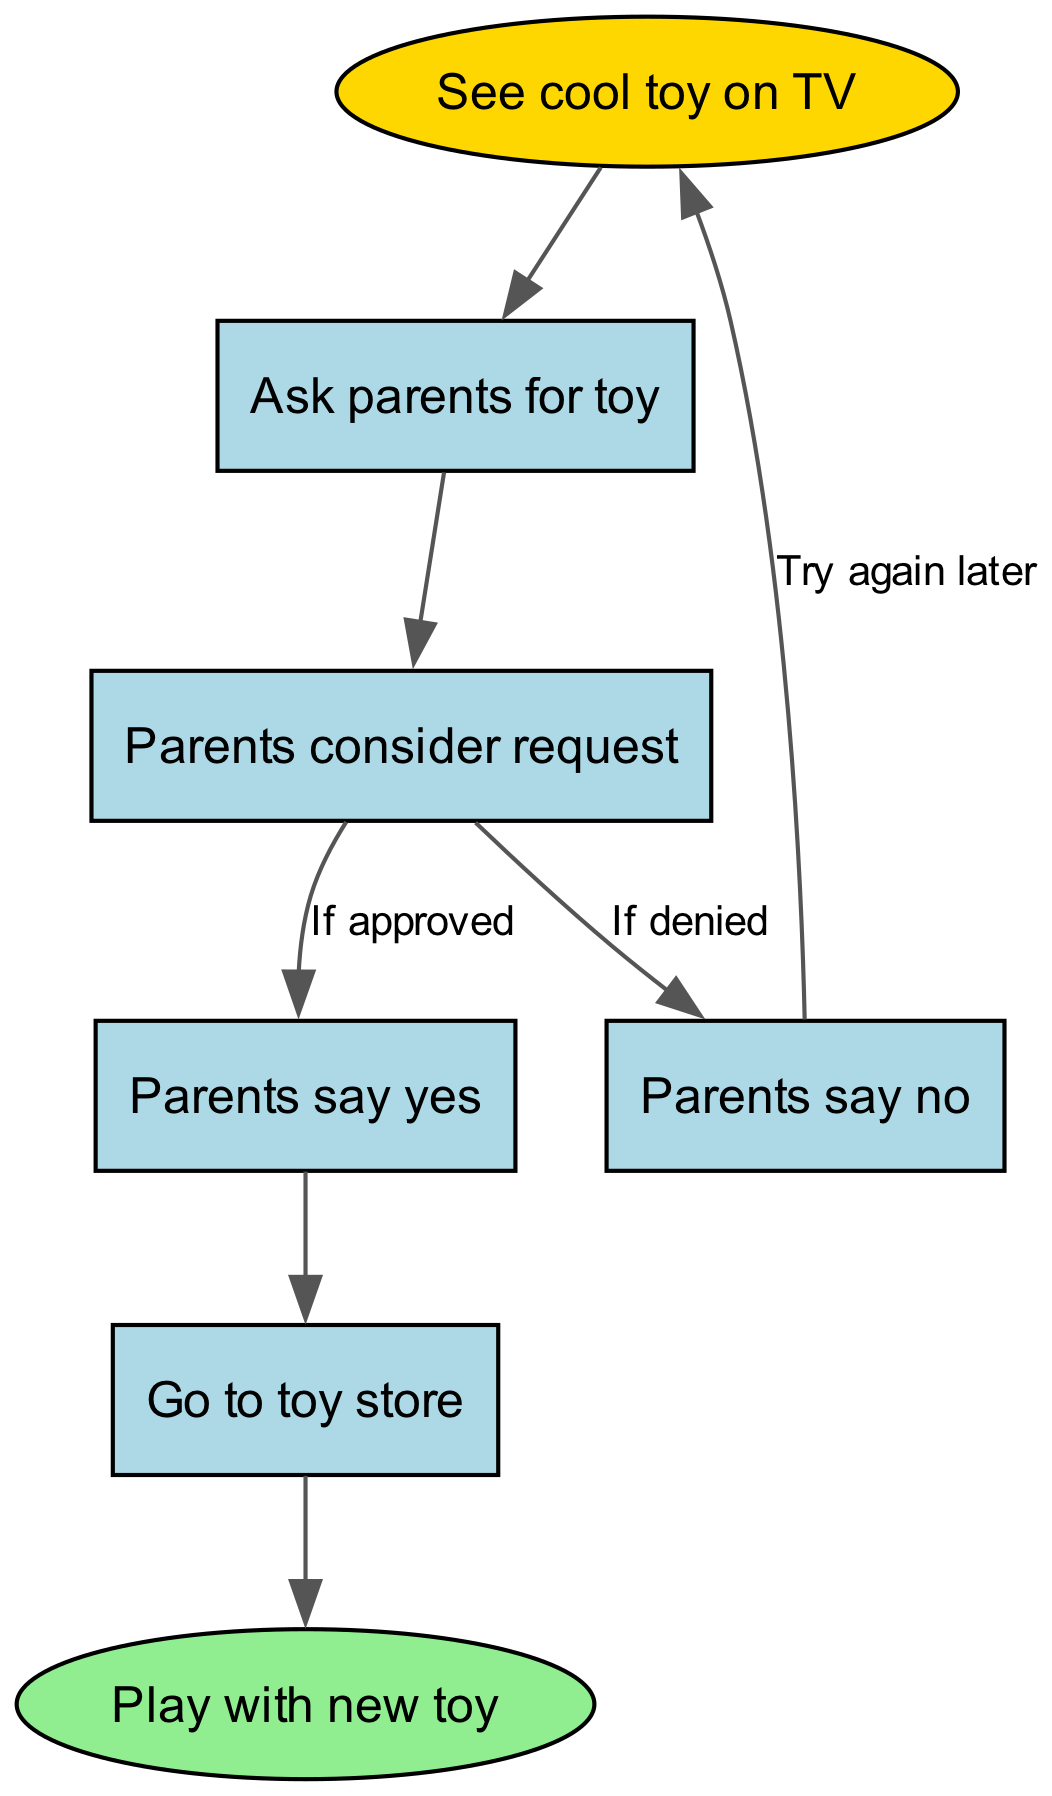What is the first step in the process? The first step is represented by the node with the ID 1, which states "See cool toy on TV." This is where the process begins.
Answer: See cool toy on TV How many total nodes are in the diagram? By counting each unique node in the nodes section of the data, there are 7 nodes: ID 1 to ID 7.
Answer: 7 What happens after asking parents for the toy? After the request to the parents (node ID 2), the next step is represented by node ID 3, which indicates that "Parents consider request."
Answer: Parents consider request What is the outcome if parents say yes? If the parents say yes (node ID 4), the process moves to node ID 6, where it specifies that "Go to toy store." This is the next action taken.
Answer: Go to toy store What do parents say if they deny the request? If the parents deny the request (node ID 5), they indicate that it is time to "Try again later," which circles back to node ID 1 to start over.
Answer: Try again later How many edges are there in total? Each edge represents a connection between two nodes. By counting all the edges listed in the data, there are 7 edges connecting the different nodes.
Answer: 7 What is the endpoint of the flowchart? The endpoint of the flowchart is represented by the final node ID 7, which indicates "Play with new toy." This is where the process concludes.
Answer: Play with new toy What step occurs if the request is denied? If the request is denied (connecting edge from node ID 3 to node ID 5), the process suggests that the child should "Try again later," which is indicated in node ID 5.
Answer: Try again later What do the parents need to do after evaluating the request? After evaluating the request (from node ID 3), the parents either approve it (node ID 4) or deny it (node ID 5), indicating they have considered the request.
Answer: Consider request 